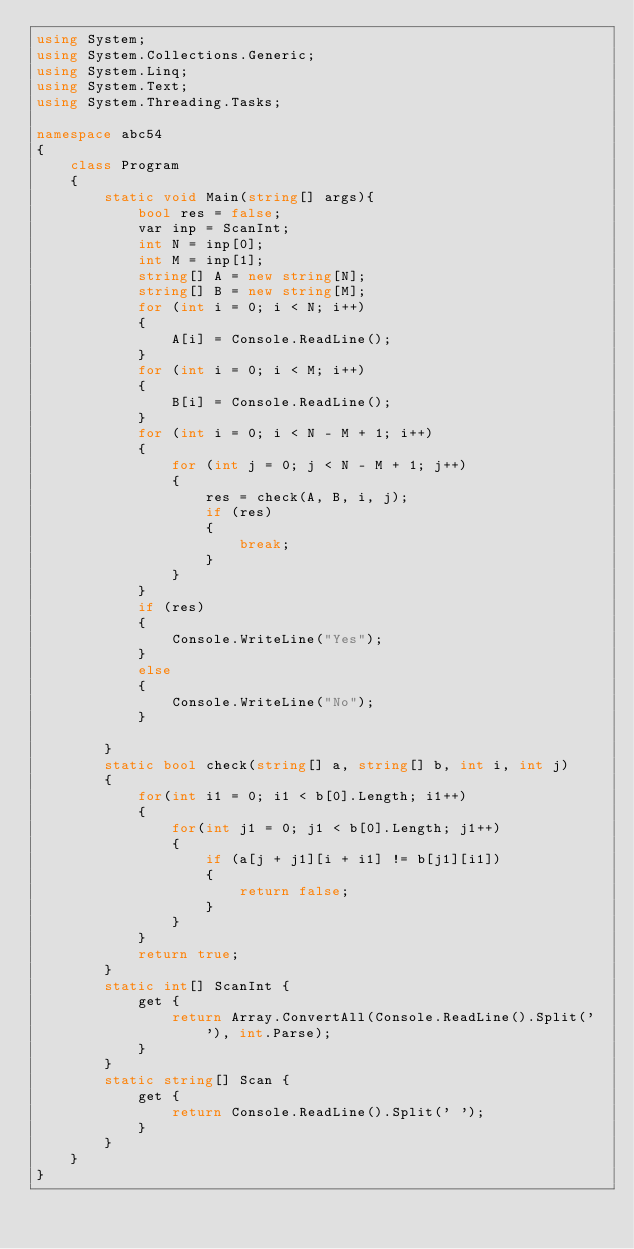<code> <loc_0><loc_0><loc_500><loc_500><_C#_>using System;
using System.Collections.Generic;
using System.Linq;
using System.Text;
using System.Threading.Tasks;

namespace abc54
{
    class Program
    {
        static void Main(string[] args){
            bool res = false;
            var inp = ScanInt;
            int N = inp[0];
            int M = inp[1];
            string[] A = new string[N];
            string[] B = new string[M];
            for (int i = 0; i < N; i++)
            {
                A[i] = Console.ReadLine();
            }
            for (int i = 0; i < M; i++)
            {
                B[i] = Console.ReadLine();
            }  
            for (int i = 0; i < N - M + 1; i++)
            {
                for (int j = 0; j < N - M + 1; j++)
                {
                    res = check(A, B, i, j);
                    if (res)
                    {
                        break;
                    }
                }
            }
            if (res)
            {
                Console.WriteLine("Yes");
            }
            else
            {
                Console.WriteLine("No");
            }

        }
        static bool check(string[] a, string[] b, int i, int j)
        {
            for(int i1 = 0; i1 < b[0].Length; i1++)
            {
                for(int j1 = 0; j1 < b[0].Length; j1++)
                {
                    if (a[j + j1][i + i1] != b[j1][i1])
                    {
                        return false;
                    }
                }
            }
            return true;
        }
        static int[] ScanInt {
            get {
                return Array.ConvertAll(Console.ReadLine().Split(' '), int.Parse);
            }
        }
        static string[] Scan {
            get {
                return Console.ReadLine().Split(' ');
            }
        }
    }
}
</code> 